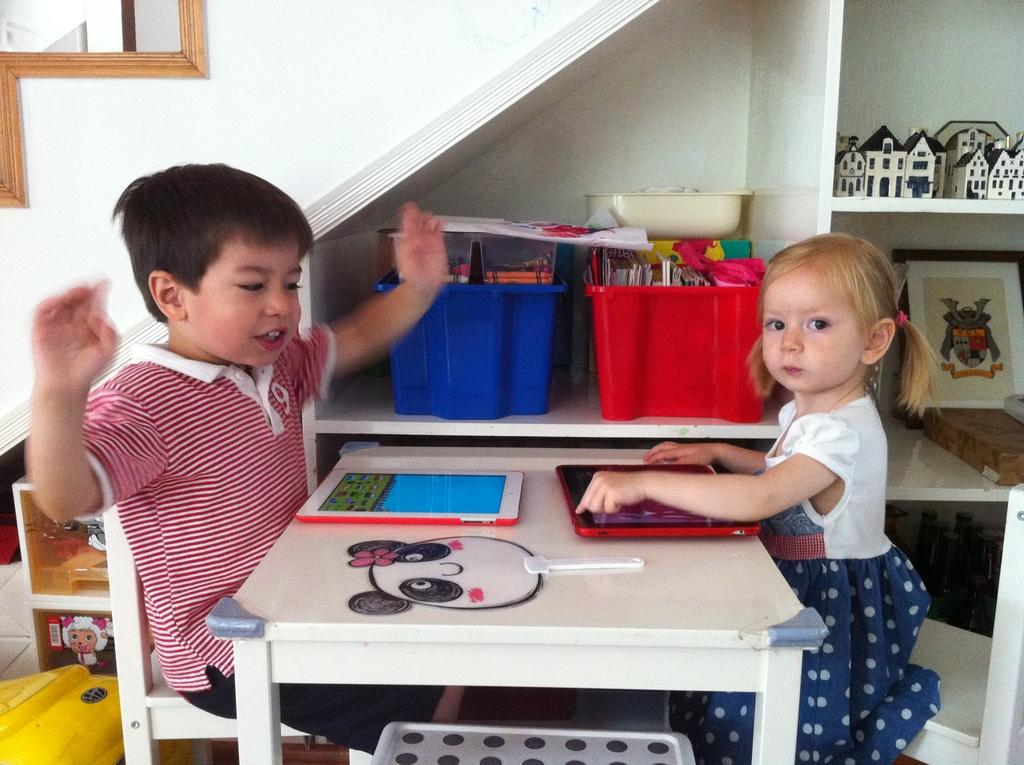Who are the people in the image? There is a boy and a girl in the image. What is in front of the boy and girl? There is a table in front of the boy and girl. What objects can be seen on the table? There are two smartphones on the table. What color is the lip of the hour on the hydrant in the image? There is no lip, hour, or hydrant present in the image. 